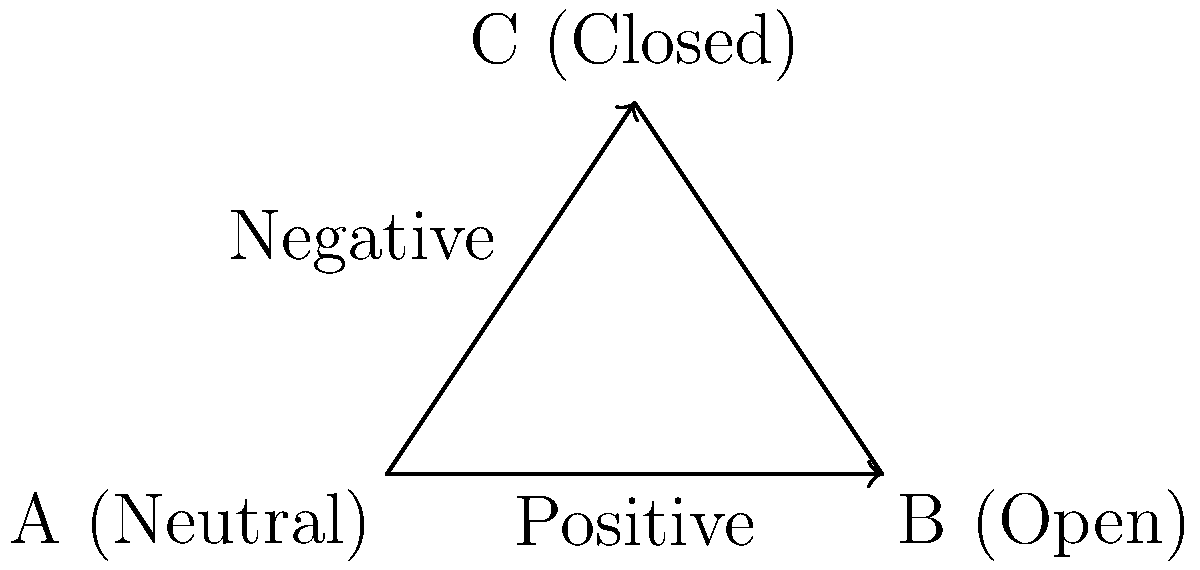In a business meeting with German executives, you notice a shift in body language from position A to position B as shown in the vector diagram. What does this likely indicate about the executives' reception to your proposal? To interpret this body language shift in a German business context, let's analyze the diagram step-by-step:

1. Point A is labeled "Neutral," representing the starting position or baseline body language.

2. There are two possible directions from point A:
   - Towards B, labeled "Open"
   - Towards C, labeled "Closed"

3. The question states that there's a shift from A to B.

4. The arrow from A to B is labeled "Positive," indicating a favorable change.

5. In German business culture, open body language typically includes:
   - Uncrossed arms
   - Direct eye contact
   - Leaning slightly forward
   - Nodding in agreement

6. Moving from a neutral position to a more open one suggests:
   - Increased interest
   - Growing comfort with the proposal
   - Willingness to engage further

7. In German business settings, this positive shift is particularly significant as Germans tend to be more reserved initially and warm up gradually.

8. This change likely indicates that the executives are becoming more receptive to your proposal and are interested in continuing the discussion.

Therefore, the shift from A to B suggests a positive reception to your proposal by the German executives.
Answer: Positive reception 